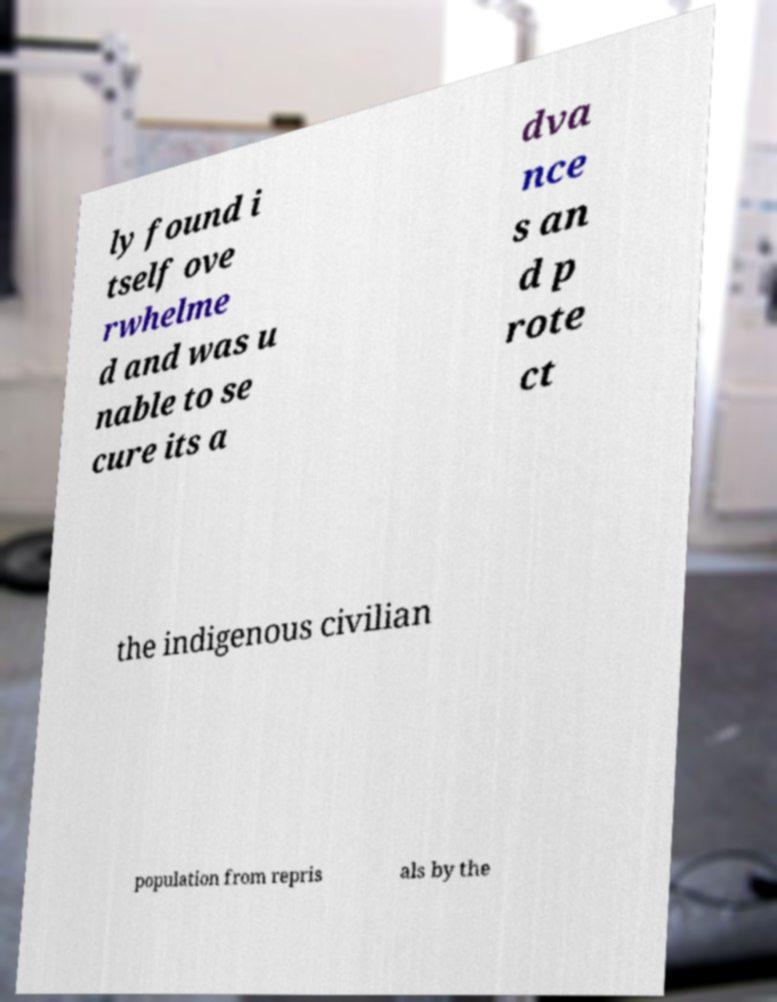There's text embedded in this image that I need extracted. Can you transcribe it verbatim? ly found i tself ove rwhelme d and was u nable to se cure its a dva nce s an d p rote ct the indigenous civilian population from repris als by the 